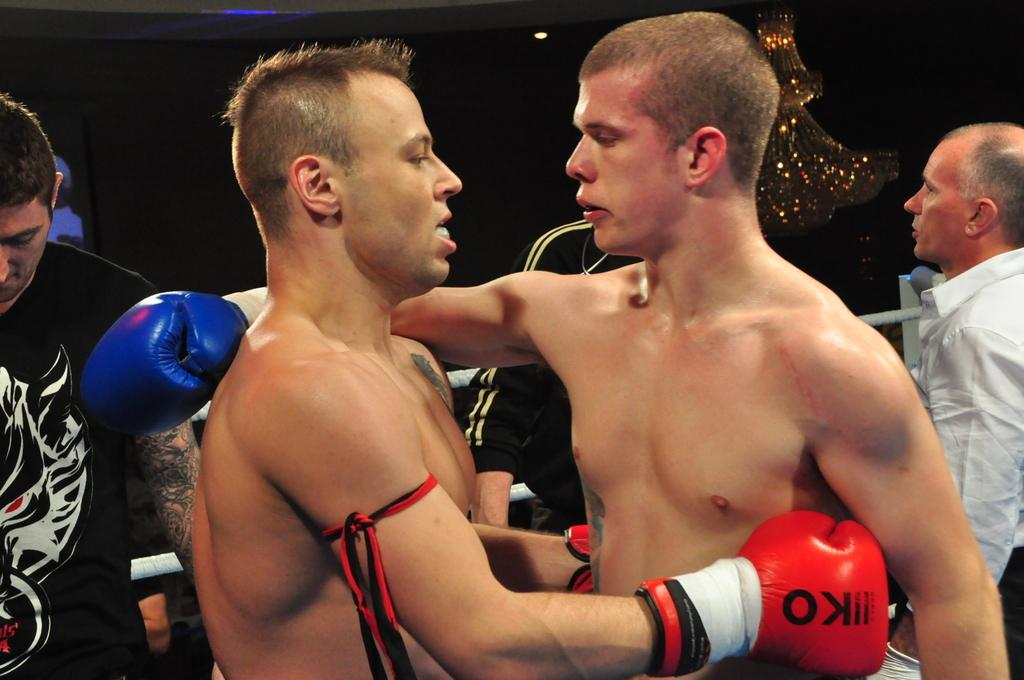<image>
Relay a brief, clear account of the picture shown. Two boxers hugging one another with one whose gloves say KO. 